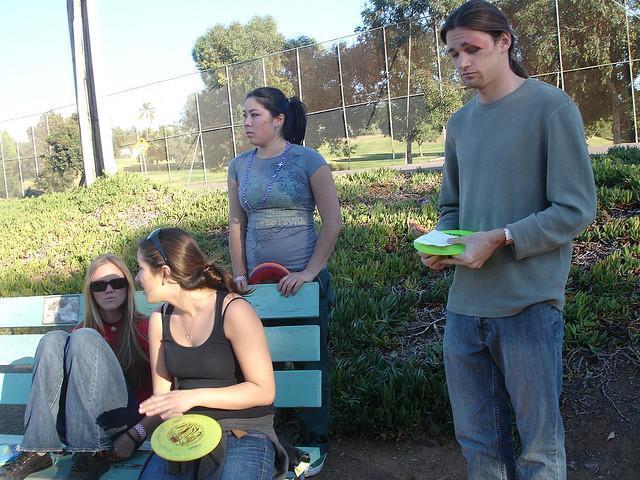What are they doing?
Pick the correct solution from the four options below to address the question.
Options: Awaiting bus, eating lunch, resting, seeking food. Eating lunch. 